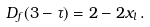<formula> <loc_0><loc_0><loc_500><loc_500>D _ { f } ( 3 - \tau ) = 2 - 2 x _ { l } \, .</formula> 